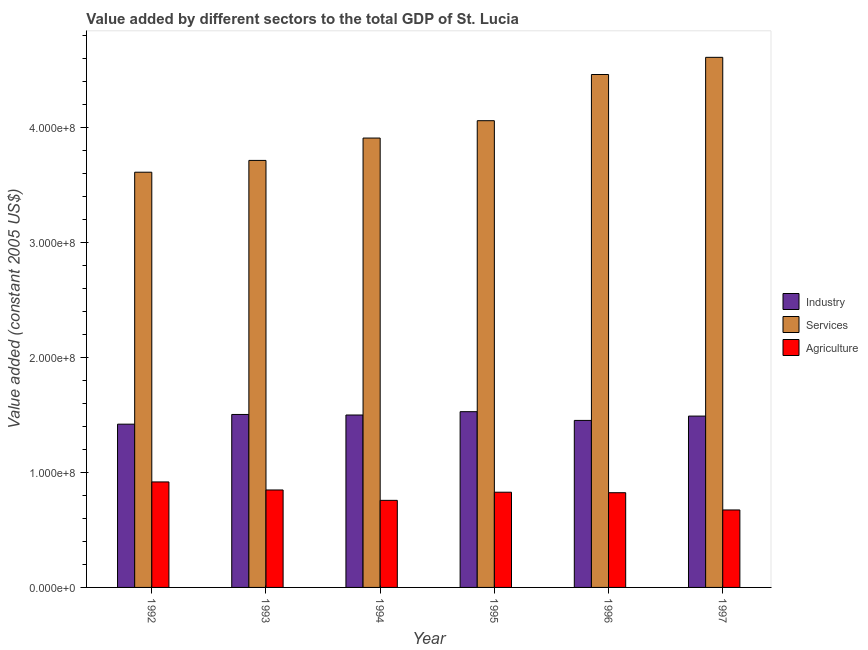How many different coloured bars are there?
Provide a short and direct response. 3. How many groups of bars are there?
Provide a short and direct response. 6. Are the number of bars on each tick of the X-axis equal?
Offer a terse response. Yes. How many bars are there on the 3rd tick from the right?
Make the answer very short. 3. What is the label of the 1st group of bars from the left?
Provide a succinct answer. 1992. In how many cases, is the number of bars for a given year not equal to the number of legend labels?
Offer a terse response. 0. What is the value added by agricultural sector in 1997?
Offer a terse response. 6.73e+07. Across all years, what is the maximum value added by services?
Offer a terse response. 4.61e+08. Across all years, what is the minimum value added by agricultural sector?
Your answer should be compact. 6.73e+07. In which year was the value added by agricultural sector maximum?
Keep it short and to the point. 1992. In which year was the value added by industrial sector minimum?
Provide a short and direct response. 1992. What is the total value added by services in the graph?
Your response must be concise. 2.43e+09. What is the difference between the value added by agricultural sector in 1995 and that in 1996?
Provide a succinct answer. 4.31e+05. What is the difference between the value added by agricultural sector in 1993 and the value added by services in 1994?
Ensure brevity in your answer.  9.02e+06. What is the average value added by industrial sector per year?
Your answer should be compact. 1.48e+08. In how many years, is the value added by industrial sector greater than 100000000 US$?
Offer a terse response. 6. What is the ratio of the value added by agricultural sector in 1994 to that in 1997?
Ensure brevity in your answer.  1.12. Is the value added by services in 1993 less than that in 1996?
Provide a succinct answer. Yes. Is the difference between the value added by industrial sector in 1992 and 1994 greater than the difference between the value added by agricultural sector in 1992 and 1994?
Your answer should be very brief. No. What is the difference between the highest and the second highest value added by agricultural sector?
Ensure brevity in your answer.  6.99e+06. What is the difference between the highest and the lowest value added by industrial sector?
Provide a short and direct response. 1.09e+07. In how many years, is the value added by services greater than the average value added by services taken over all years?
Your answer should be very brief. 2. Is the sum of the value added by agricultural sector in 1993 and 1996 greater than the maximum value added by industrial sector across all years?
Your response must be concise. Yes. What does the 2nd bar from the left in 1994 represents?
Your response must be concise. Services. What does the 3rd bar from the right in 1995 represents?
Your answer should be compact. Industry. Is it the case that in every year, the sum of the value added by industrial sector and value added by services is greater than the value added by agricultural sector?
Your response must be concise. Yes. How many bars are there?
Give a very brief answer. 18. Are all the bars in the graph horizontal?
Your response must be concise. No. What is the difference between two consecutive major ticks on the Y-axis?
Provide a short and direct response. 1.00e+08. What is the title of the graph?
Keep it short and to the point. Value added by different sectors to the total GDP of St. Lucia. Does "Tertiary" appear as one of the legend labels in the graph?
Provide a short and direct response. No. What is the label or title of the Y-axis?
Ensure brevity in your answer.  Value added (constant 2005 US$). What is the Value added (constant 2005 US$) in Industry in 1992?
Ensure brevity in your answer.  1.42e+08. What is the Value added (constant 2005 US$) in Services in 1992?
Your answer should be compact. 3.61e+08. What is the Value added (constant 2005 US$) in Agriculture in 1992?
Offer a very short reply. 9.17e+07. What is the Value added (constant 2005 US$) of Industry in 1993?
Give a very brief answer. 1.50e+08. What is the Value added (constant 2005 US$) in Services in 1993?
Your response must be concise. 3.71e+08. What is the Value added (constant 2005 US$) in Agriculture in 1993?
Provide a succinct answer. 8.47e+07. What is the Value added (constant 2005 US$) in Industry in 1994?
Offer a very short reply. 1.50e+08. What is the Value added (constant 2005 US$) in Services in 1994?
Give a very brief answer. 3.91e+08. What is the Value added (constant 2005 US$) in Agriculture in 1994?
Your answer should be very brief. 7.57e+07. What is the Value added (constant 2005 US$) of Industry in 1995?
Offer a very short reply. 1.53e+08. What is the Value added (constant 2005 US$) of Services in 1995?
Keep it short and to the point. 4.06e+08. What is the Value added (constant 2005 US$) of Agriculture in 1995?
Offer a terse response. 8.27e+07. What is the Value added (constant 2005 US$) in Industry in 1996?
Offer a terse response. 1.45e+08. What is the Value added (constant 2005 US$) of Services in 1996?
Provide a short and direct response. 4.46e+08. What is the Value added (constant 2005 US$) of Agriculture in 1996?
Your answer should be very brief. 8.23e+07. What is the Value added (constant 2005 US$) of Industry in 1997?
Give a very brief answer. 1.49e+08. What is the Value added (constant 2005 US$) of Services in 1997?
Your response must be concise. 4.61e+08. What is the Value added (constant 2005 US$) in Agriculture in 1997?
Offer a terse response. 6.73e+07. Across all years, what is the maximum Value added (constant 2005 US$) in Industry?
Offer a terse response. 1.53e+08. Across all years, what is the maximum Value added (constant 2005 US$) of Services?
Your response must be concise. 4.61e+08. Across all years, what is the maximum Value added (constant 2005 US$) of Agriculture?
Your answer should be very brief. 9.17e+07. Across all years, what is the minimum Value added (constant 2005 US$) in Industry?
Offer a very short reply. 1.42e+08. Across all years, what is the minimum Value added (constant 2005 US$) in Services?
Provide a short and direct response. 3.61e+08. Across all years, what is the minimum Value added (constant 2005 US$) in Agriculture?
Provide a short and direct response. 6.73e+07. What is the total Value added (constant 2005 US$) in Industry in the graph?
Your response must be concise. 8.89e+08. What is the total Value added (constant 2005 US$) of Services in the graph?
Your response must be concise. 2.43e+09. What is the total Value added (constant 2005 US$) in Agriculture in the graph?
Your response must be concise. 4.84e+08. What is the difference between the Value added (constant 2005 US$) of Industry in 1992 and that in 1993?
Your response must be concise. -8.43e+06. What is the difference between the Value added (constant 2005 US$) of Services in 1992 and that in 1993?
Offer a terse response. -1.03e+07. What is the difference between the Value added (constant 2005 US$) of Agriculture in 1992 and that in 1993?
Offer a terse response. 6.99e+06. What is the difference between the Value added (constant 2005 US$) of Industry in 1992 and that in 1994?
Keep it short and to the point. -7.95e+06. What is the difference between the Value added (constant 2005 US$) in Services in 1992 and that in 1994?
Ensure brevity in your answer.  -2.97e+07. What is the difference between the Value added (constant 2005 US$) of Agriculture in 1992 and that in 1994?
Offer a very short reply. 1.60e+07. What is the difference between the Value added (constant 2005 US$) of Industry in 1992 and that in 1995?
Ensure brevity in your answer.  -1.09e+07. What is the difference between the Value added (constant 2005 US$) in Services in 1992 and that in 1995?
Provide a short and direct response. -4.48e+07. What is the difference between the Value added (constant 2005 US$) in Agriculture in 1992 and that in 1995?
Your answer should be compact. 8.94e+06. What is the difference between the Value added (constant 2005 US$) of Industry in 1992 and that in 1996?
Make the answer very short. -3.25e+06. What is the difference between the Value added (constant 2005 US$) of Services in 1992 and that in 1996?
Offer a terse response. -8.49e+07. What is the difference between the Value added (constant 2005 US$) in Agriculture in 1992 and that in 1996?
Your answer should be very brief. 9.37e+06. What is the difference between the Value added (constant 2005 US$) in Industry in 1992 and that in 1997?
Provide a short and direct response. -7.01e+06. What is the difference between the Value added (constant 2005 US$) of Services in 1992 and that in 1997?
Provide a succinct answer. -9.98e+07. What is the difference between the Value added (constant 2005 US$) of Agriculture in 1992 and that in 1997?
Offer a terse response. 2.44e+07. What is the difference between the Value added (constant 2005 US$) in Industry in 1993 and that in 1994?
Your answer should be compact. 4.80e+05. What is the difference between the Value added (constant 2005 US$) in Services in 1993 and that in 1994?
Your answer should be compact. -1.94e+07. What is the difference between the Value added (constant 2005 US$) in Agriculture in 1993 and that in 1994?
Make the answer very short. 9.02e+06. What is the difference between the Value added (constant 2005 US$) in Industry in 1993 and that in 1995?
Provide a short and direct response. -2.42e+06. What is the difference between the Value added (constant 2005 US$) of Services in 1993 and that in 1995?
Give a very brief answer. -3.45e+07. What is the difference between the Value added (constant 2005 US$) in Agriculture in 1993 and that in 1995?
Give a very brief answer. 1.95e+06. What is the difference between the Value added (constant 2005 US$) in Industry in 1993 and that in 1996?
Offer a terse response. 5.18e+06. What is the difference between the Value added (constant 2005 US$) of Services in 1993 and that in 1996?
Your answer should be very brief. -7.47e+07. What is the difference between the Value added (constant 2005 US$) in Agriculture in 1993 and that in 1996?
Your answer should be compact. 2.38e+06. What is the difference between the Value added (constant 2005 US$) in Industry in 1993 and that in 1997?
Keep it short and to the point. 1.42e+06. What is the difference between the Value added (constant 2005 US$) of Services in 1993 and that in 1997?
Give a very brief answer. -8.96e+07. What is the difference between the Value added (constant 2005 US$) of Agriculture in 1993 and that in 1997?
Provide a short and direct response. 1.74e+07. What is the difference between the Value added (constant 2005 US$) in Industry in 1994 and that in 1995?
Make the answer very short. -2.90e+06. What is the difference between the Value added (constant 2005 US$) in Services in 1994 and that in 1995?
Your response must be concise. -1.51e+07. What is the difference between the Value added (constant 2005 US$) in Agriculture in 1994 and that in 1995?
Ensure brevity in your answer.  -7.07e+06. What is the difference between the Value added (constant 2005 US$) of Industry in 1994 and that in 1996?
Give a very brief answer. 4.70e+06. What is the difference between the Value added (constant 2005 US$) of Services in 1994 and that in 1996?
Provide a succinct answer. -5.52e+07. What is the difference between the Value added (constant 2005 US$) of Agriculture in 1994 and that in 1996?
Your answer should be very brief. -6.64e+06. What is the difference between the Value added (constant 2005 US$) in Industry in 1994 and that in 1997?
Ensure brevity in your answer.  9.38e+05. What is the difference between the Value added (constant 2005 US$) in Services in 1994 and that in 1997?
Your answer should be compact. -7.01e+07. What is the difference between the Value added (constant 2005 US$) of Agriculture in 1994 and that in 1997?
Keep it short and to the point. 8.36e+06. What is the difference between the Value added (constant 2005 US$) in Industry in 1995 and that in 1996?
Provide a short and direct response. 7.60e+06. What is the difference between the Value added (constant 2005 US$) of Services in 1995 and that in 1996?
Your response must be concise. -4.01e+07. What is the difference between the Value added (constant 2005 US$) of Agriculture in 1995 and that in 1996?
Your answer should be compact. 4.31e+05. What is the difference between the Value added (constant 2005 US$) of Industry in 1995 and that in 1997?
Your answer should be very brief. 3.84e+06. What is the difference between the Value added (constant 2005 US$) in Services in 1995 and that in 1997?
Give a very brief answer. -5.51e+07. What is the difference between the Value added (constant 2005 US$) in Agriculture in 1995 and that in 1997?
Your answer should be very brief. 1.54e+07. What is the difference between the Value added (constant 2005 US$) of Industry in 1996 and that in 1997?
Give a very brief answer. -3.76e+06. What is the difference between the Value added (constant 2005 US$) of Services in 1996 and that in 1997?
Your answer should be compact. -1.49e+07. What is the difference between the Value added (constant 2005 US$) in Agriculture in 1996 and that in 1997?
Keep it short and to the point. 1.50e+07. What is the difference between the Value added (constant 2005 US$) of Industry in 1992 and the Value added (constant 2005 US$) of Services in 1993?
Your answer should be very brief. -2.29e+08. What is the difference between the Value added (constant 2005 US$) in Industry in 1992 and the Value added (constant 2005 US$) in Agriculture in 1993?
Give a very brief answer. 5.72e+07. What is the difference between the Value added (constant 2005 US$) in Services in 1992 and the Value added (constant 2005 US$) in Agriculture in 1993?
Your response must be concise. 2.76e+08. What is the difference between the Value added (constant 2005 US$) in Industry in 1992 and the Value added (constant 2005 US$) in Services in 1994?
Your answer should be very brief. -2.49e+08. What is the difference between the Value added (constant 2005 US$) in Industry in 1992 and the Value added (constant 2005 US$) in Agriculture in 1994?
Your response must be concise. 6.62e+07. What is the difference between the Value added (constant 2005 US$) in Services in 1992 and the Value added (constant 2005 US$) in Agriculture in 1994?
Keep it short and to the point. 2.85e+08. What is the difference between the Value added (constant 2005 US$) of Industry in 1992 and the Value added (constant 2005 US$) of Services in 1995?
Your answer should be compact. -2.64e+08. What is the difference between the Value added (constant 2005 US$) of Industry in 1992 and the Value added (constant 2005 US$) of Agriculture in 1995?
Keep it short and to the point. 5.91e+07. What is the difference between the Value added (constant 2005 US$) of Services in 1992 and the Value added (constant 2005 US$) of Agriculture in 1995?
Ensure brevity in your answer.  2.78e+08. What is the difference between the Value added (constant 2005 US$) of Industry in 1992 and the Value added (constant 2005 US$) of Services in 1996?
Offer a terse response. -3.04e+08. What is the difference between the Value added (constant 2005 US$) in Industry in 1992 and the Value added (constant 2005 US$) in Agriculture in 1996?
Offer a terse response. 5.96e+07. What is the difference between the Value added (constant 2005 US$) in Services in 1992 and the Value added (constant 2005 US$) in Agriculture in 1996?
Make the answer very short. 2.79e+08. What is the difference between the Value added (constant 2005 US$) in Industry in 1992 and the Value added (constant 2005 US$) in Services in 1997?
Your answer should be very brief. -3.19e+08. What is the difference between the Value added (constant 2005 US$) in Industry in 1992 and the Value added (constant 2005 US$) in Agriculture in 1997?
Your answer should be compact. 7.46e+07. What is the difference between the Value added (constant 2005 US$) of Services in 1992 and the Value added (constant 2005 US$) of Agriculture in 1997?
Your answer should be compact. 2.94e+08. What is the difference between the Value added (constant 2005 US$) of Industry in 1993 and the Value added (constant 2005 US$) of Services in 1994?
Offer a very short reply. -2.40e+08. What is the difference between the Value added (constant 2005 US$) of Industry in 1993 and the Value added (constant 2005 US$) of Agriculture in 1994?
Give a very brief answer. 7.46e+07. What is the difference between the Value added (constant 2005 US$) of Services in 1993 and the Value added (constant 2005 US$) of Agriculture in 1994?
Your answer should be very brief. 2.95e+08. What is the difference between the Value added (constant 2005 US$) in Industry in 1993 and the Value added (constant 2005 US$) in Services in 1995?
Provide a succinct answer. -2.55e+08. What is the difference between the Value added (constant 2005 US$) in Industry in 1993 and the Value added (constant 2005 US$) in Agriculture in 1995?
Provide a succinct answer. 6.76e+07. What is the difference between the Value added (constant 2005 US$) of Services in 1993 and the Value added (constant 2005 US$) of Agriculture in 1995?
Your response must be concise. 2.88e+08. What is the difference between the Value added (constant 2005 US$) of Industry in 1993 and the Value added (constant 2005 US$) of Services in 1996?
Provide a succinct answer. -2.95e+08. What is the difference between the Value added (constant 2005 US$) in Industry in 1993 and the Value added (constant 2005 US$) in Agriculture in 1996?
Give a very brief answer. 6.80e+07. What is the difference between the Value added (constant 2005 US$) in Services in 1993 and the Value added (constant 2005 US$) in Agriculture in 1996?
Give a very brief answer. 2.89e+08. What is the difference between the Value added (constant 2005 US$) of Industry in 1993 and the Value added (constant 2005 US$) of Services in 1997?
Your answer should be very brief. -3.10e+08. What is the difference between the Value added (constant 2005 US$) in Industry in 1993 and the Value added (constant 2005 US$) in Agriculture in 1997?
Provide a succinct answer. 8.30e+07. What is the difference between the Value added (constant 2005 US$) in Services in 1993 and the Value added (constant 2005 US$) in Agriculture in 1997?
Make the answer very short. 3.04e+08. What is the difference between the Value added (constant 2005 US$) of Industry in 1994 and the Value added (constant 2005 US$) of Services in 1995?
Your answer should be very brief. -2.56e+08. What is the difference between the Value added (constant 2005 US$) of Industry in 1994 and the Value added (constant 2005 US$) of Agriculture in 1995?
Make the answer very short. 6.71e+07. What is the difference between the Value added (constant 2005 US$) of Services in 1994 and the Value added (constant 2005 US$) of Agriculture in 1995?
Make the answer very short. 3.08e+08. What is the difference between the Value added (constant 2005 US$) of Industry in 1994 and the Value added (constant 2005 US$) of Services in 1996?
Your response must be concise. -2.96e+08. What is the difference between the Value added (constant 2005 US$) in Industry in 1994 and the Value added (constant 2005 US$) in Agriculture in 1996?
Your answer should be compact. 6.75e+07. What is the difference between the Value added (constant 2005 US$) of Services in 1994 and the Value added (constant 2005 US$) of Agriculture in 1996?
Keep it short and to the point. 3.08e+08. What is the difference between the Value added (constant 2005 US$) of Industry in 1994 and the Value added (constant 2005 US$) of Services in 1997?
Provide a succinct answer. -3.11e+08. What is the difference between the Value added (constant 2005 US$) of Industry in 1994 and the Value added (constant 2005 US$) of Agriculture in 1997?
Your answer should be very brief. 8.25e+07. What is the difference between the Value added (constant 2005 US$) of Services in 1994 and the Value added (constant 2005 US$) of Agriculture in 1997?
Your answer should be compact. 3.23e+08. What is the difference between the Value added (constant 2005 US$) in Industry in 1995 and the Value added (constant 2005 US$) in Services in 1996?
Give a very brief answer. -2.93e+08. What is the difference between the Value added (constant 2005 US$) of Industry in 1995 and the Value added (constant 2005 US$) of Agriculture in 1996?
Ensure brevity in your answer.  7.04e+07. What is the difference between the Value added (constant 2005 US$) in Services in 1995 and the Value added (constant 2005 US$) in Agriculture in 1996?
Offer a very short reply. 3.23e+08. What is the difference between the Value added (constant 2005 US$) of Industry in 1995 and the Value added (constant 2005 US$) of Services in 1997?
Provide a short and direct response. -3.08e+08. What is the difference between the Value added (constant 2005 US$) of Industry in 1995 and the Value added (constant 2005 US$) of Agriculture in 1997?
Your answer should be very brief. 8.54e+07. What is the difference between the Value added (constant 2005 US$) of Services in 1995 and the Value added (constant 2005 US$) of Agriculture in 1997?
Ensure brevity in your answer.  3.38e+08. What is the difference between the Value added (constant 2005 US$) of Industry in 1996 and the Value added (constant 2005 US$) of Services in 1997?
Give a very brief answer. -3.16e+08. What is the difference between the Value added (constant 2005 US$) of Industry in 1996 and the Value added (constant 2005 US$) of Agriculture in 1997?
Your response must be concise. 7.78e+07. What is the difference between the Value added (constant 2005 US$) in Services in 1996 and the Value added (constant 2005 US$) in Agriculture in 1997?
Your answer should be compact. 3.78e+08. What is the average Value added (constant 2005 US$) in Industry per year?
Your response must be concise. 1.48e+08. What is the average Value added (constant 2005 US$) in Services per year?
Keep it short and to the point. 4.06e+08. What is the average Value added (constant 2005 US$) of Agriculture per year?
Give a very brief answer. 8.07e+07. In the year 1992, what is the difference between the Value added (constant 2005 US$) of Industry and Value added (constant 2005 US$) of Services?
Offer a very short reply. -2.19e+08. In the year 1992, what is the difference between the Value added (constant 2005 US$) in Industry and Value added (constant 2005 US$) in Agriculture?
Offer a very short reply. 5.02e+07. In the year 1992, what is the difference between the Value added (constant 2005 US$) in Services and Value added (constant 2005 US$) in Agriculture?
Provide a succinct answer. 2.69e+08. In the year 1993, what is the difference between the Value added (constant 2005 US$) in Industry and Value added (constant 2005 US$) in Services?
Offer a very short reply. -2.21e+08. In the year 1993, what is the difference between the Value added (constant 2005 US$) in Industry and Value added (constant 2005 US$) in Agriculture?
Offer a terse response. 6.56e+07. In the year 1993, what is the difference between the Value added (constant 2005 US$) in Services and Value added (constant 2005 US$) in Agriculture?
Ensure brevity in your answer.  2.86e+08. In the year 1994, what is the difference between the Value added (constant 2005 US$) of Industry and Value added (constant 2005 US$) of Services?
Offer a very short reply. -2.41e+08. In the year 1994, what is the difference between the Value added (constant 2005 US$) in Industry and Value added (constant 2005 US$) in Agriculture?
Ensure brevity in your answer.  7.42e+07. In the year 1994, what is the difference between the Value added (constant 2005 US$) in Services and Value added (constant 2005 US$) in Agriculture?
Your answer should be very brief. 3.15e+08. In the year 1995, what is the difference between the Value added (constant 2005 US$) in Industry and Value added (constant 2005 US$) in Services?
Provide a short and direct response. -2.53e+08. In the year 1995, what is the difference between the Value added (constant 2005 US$) of Industry and Value added (constant 2005 US$) of Agriculture?
Your answer should be compact. 7.00e+07. In the year 1995, what is the difference between the Value added (constant 2005 US$) in Services and Value added (constant 2005 US$) in Agriculture?
Your answer should be very brief. 3.23e+08. In the year 1996, what is the difference between the Value added (constant 2005 US$) in Industry and Value added (constant 2005 US$) in Services?
Provide a succinct answer. -3.01e+08. In the year 1996, what is the difference between the Value added (constant 2005 US$) in Industry and Value added (constant 2005 US$) in Agriculture?
Your answer should be compact. 6.28e+07. In the year 1996, what is the difference between the Value added (constant 2005 US$) of Services and Value added (constant 2005 US$) of Agriculture?
Your response must be concise. 3.63e+08. In the year 1997, what is the difference between the Value added (constant 2005 US$) of Industry and Value added (constant 2005 US$) of Services?
Give a very brief answer. -3.12e+08. In the year 1997, what is the difference between the Value added (constant 2005 US$) of Industry and Value added (constant 2005 US$) of Agriculture?
Ensure brevity in your answer.  8.16e+07. In the year 1997, what is the difference between the Value added (constant 2005 US$) of Services and Value added (constant 2005 US$) of Agriculture?
Keep it short and to the point. 3.93e+08. What is the ratio of the Value added (constant 2005 US$) of Industry in 1992 to that in 1993?
Your answer should be very brief. 0.94. What is the ratio of the Value added (constant 2005 US$) in Services in 1992 to that in 1993?
Ensure brevity in your answer.  0.97. What is the ratio of the Value added (constant 2005 US$) in Agriculture in 1992 to that in 1993?
Offer a terse response. 1.08. What is the ratio of the Value added (constant 2005 US$) of Industry in 1992 to that in 1994?
Your answer should be very brief. 0.95. What is the ratio of the Value added (constant 2005 US$) of Services in 1992 to that in 1994?
Make the answer very short. 0.92. What is the ratio of the Value added (constant 2005 US$) in Agriculture in 1992 to that in 1994?
Give a very brief answer. 1.21. What is the ratio of the Value added (constant 2005 US$) in Industry in 1992 to that in 1995?
Your response must be concise. 0.93. What is the ratio of the Value added (constant 2005 US$) in Services in 1992 to that in 1995?
Make the answer very short. 0.89. What is the ratio of the Value added (constant 2005 US$) in Agriculture in 1992 to that in 1995?
Provide a succinct answer. 1.11. What is the ratio of the Value added (constant 2005 US$) of Industry in 1992 to that in 1996?
Ensure brevity in your answer.  0.98. What is the ratio of the Value added (constant 2005 US$) of Services in 1992 to that in 1996?
Your answer should be very brief. 0.81. What is the ratio of the Value added (constant 2005 US$) in Agriculture in 1992 to that in 1996?
Provide a short and direct response. 1.11. What is the ratio of the Value added (constant 2005 US$) of Industry in 1992 to that in 1997?
Your answer should be very brief. 0.95. What is the ratio of the Value added (constant 2005 US$) in Services in 1992 to that in 1997?
Make the answer very short. 0.78. What is the ratio of the Value added (constant 2005 US$) of Agriculture in 1992 to that in 1997?
Ensure brevity in your answer.  1.36. What is the ratio of the Value added (constant 2005 US$) of Services in 1993 to that in 1994?
Offer a very short reply. 0.95. What is the ratio of the Value added (constant 2005 US$) in Agriculture in 1993 to that in 1994?
Make the answer very short. 1.12. What is the ratio of the Value added (constant 2005 US$) in Industry in 1993 to that in 1995?
Keep it short and to the point. 0.98. What is the ratio of the Value added (constant 2005 US$) in Services in 1993 to that in 1995?
Make the answer very short. 0.91. What is the ratio of the Value added (constant 2005 US$) of Agriculture in 1993 to that in 1995?
Offer a very short reply. 1.02. What is the ratio of the Value added (constant 2005 US$) of Industry in 1993 to that in 1996?
Your response must be concise. 1.04. What is the ratio of the Value added (constant 2005 US$) in Services in 1993 to that in 1996?
Give a very brief answer. 0.83. What is the ratio of the Value added (constant 2005 US$) in Agriculture in 1993 to that in 1996?
Your answer should be very brief. 1.03. What is the ratio of the Value added (constant 2005 US$) in Industry in 1993 to that in 1997?
Offer a very short reply. 1.01. What is the ratio of the Value added (constant 2005 US$) in Services in 1993 to that in 1997?
Provide a succinct answer. 0.81. What is the ratio of the Value added (constant 2005 US$) in Agriculture in 1993 to that in 1997?
Give a very brief answer. 1.26. What is the ratio of the Value added (constant 2005 US$) in Industry in 1994 to that in 1995?
Your response must be concise. 0.98. What is the ratio of the Value added (constant 2005 US$) in Services in 1994 to that in 1995?
Your answer should be very brief. 0.96. What is the ratio of the Value added (constant 2005 US$) of Agriculture in 1994 to that in 1995?
Your response must be concise. 0.91. What is the ratio of the Value added (constant 2005 US$) in Industry in 1994 to that in 1996?
Offer a very short reply. 1.03. What is the ratio of the Value added (constant 2005 US$) of Services in 1994 to that in 1996?
Provide a short and direct response. 0.88. What is the ratio of the Value added (constant 2005 US$) in Agriculture in 1994 to that in 1996?
Keep it short and to the point. 0.92. What is the ratio of the Value added (constant 2005 US$) in Services in 1994 to that in 1997?
Offer a terse response. 0.85. What is the ratio of the Value added (constant 2005 US$) in Agriculture in 1994 to that in 1997?
Ensure brevity in your answer.  1.12. What is the ratio of the Value added (constant 2005 US$) in Industry in 1995 to that in 1996?
Make the answer very short. 1.05. What is the ratio of the Value added (constant 2005 US$) in Services in 1995 to that in 1996?
Ensure brevity in your answer.  0.91. What is the ratio of the Value added (constant 2005 US$) in Industry in 1995 to that in 1997?
Offer a terse response. 1.03. What is the ratio of the Value added (constant 2005 US$) of Services in 1995 to that in 1997?
Ensure brevity in your answer.  0.88. What is the ratio of the Value added (constant 2005 US$) of Agriculture in 1995 to that in 1997?
Provide a short and direct response. 1.23. What is the ratio of the Value added (constant 2005 US$) in Industry in 1996 to that in 1997?
Give a very brief answer. 0.97. What is the ratio of the Value added (constant 2005 US$) of Services in 1996 to that in 1997?
Give a very brief answer. 0.97. What is the ratio of the Value added (constant 2005 US$) of Agriculture in 1996 to that in 1997?
Provide a succinct answer. 1.22. What is the difference between the highest and the second highest Value added (constant 2005 US$) of Industry?
Your answer should be compact. 2.42e+06. What is the difference between the highest and the second highest Value added (constant 2005 US$) in Services?
Give a very brief answer. 1.49e+07. What is the difference between the highest and the second highest Value added (constant 2005 US$) of Agriculture?
Offer a very short reply. 6.99e+06. What is the difference between the highest and the lowest Value added (constant 2005 US$) of Industry?
Your answer should be very brief. 1.09e+07. What is the difference between the highest and the lowest Value added (constant 2005 US$) in Services?
Offer a very short reply. 9.98e+07. What is the difference between the highest and the lowest Value added (constant 2005 US$) in Agriculture?
Your response must be concise. 2.44e+07. 